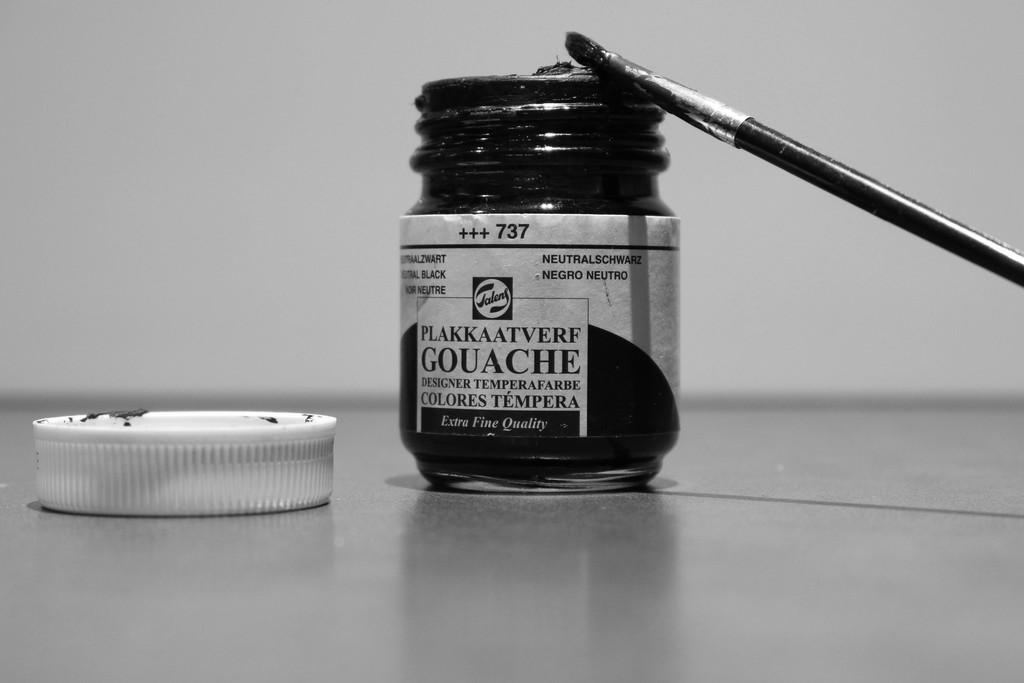Provide a one-sentence caption for the provided image. A jar of Plakkaatverf Gouache is open with the lid next to it. 